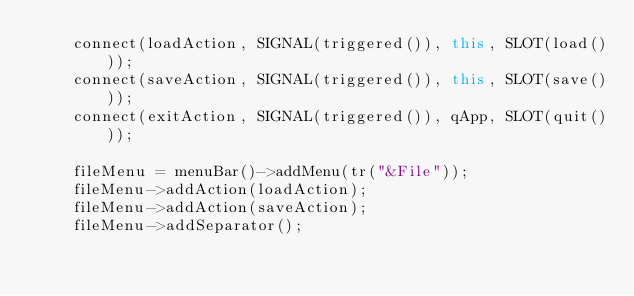<code> <loc_0><loc_0><loc_500><loc_500><_C++_>    connect(loadAction, SIGNAL(triggered()), this, SLOT(load()));
    connect(saveAction, SIGNAL(triggered()), this, SLOT(save()));
    connect(exitAction, SIGNAL(triggered()), qApp, SLOT(quit()));

    fileMenu = menuBar()->addMenu(tr("&File"));
    fileMenu->addAction(loadAction);
    fileMenu->addAction(saveAction);
    fileMenu->addSeparator();</code> 